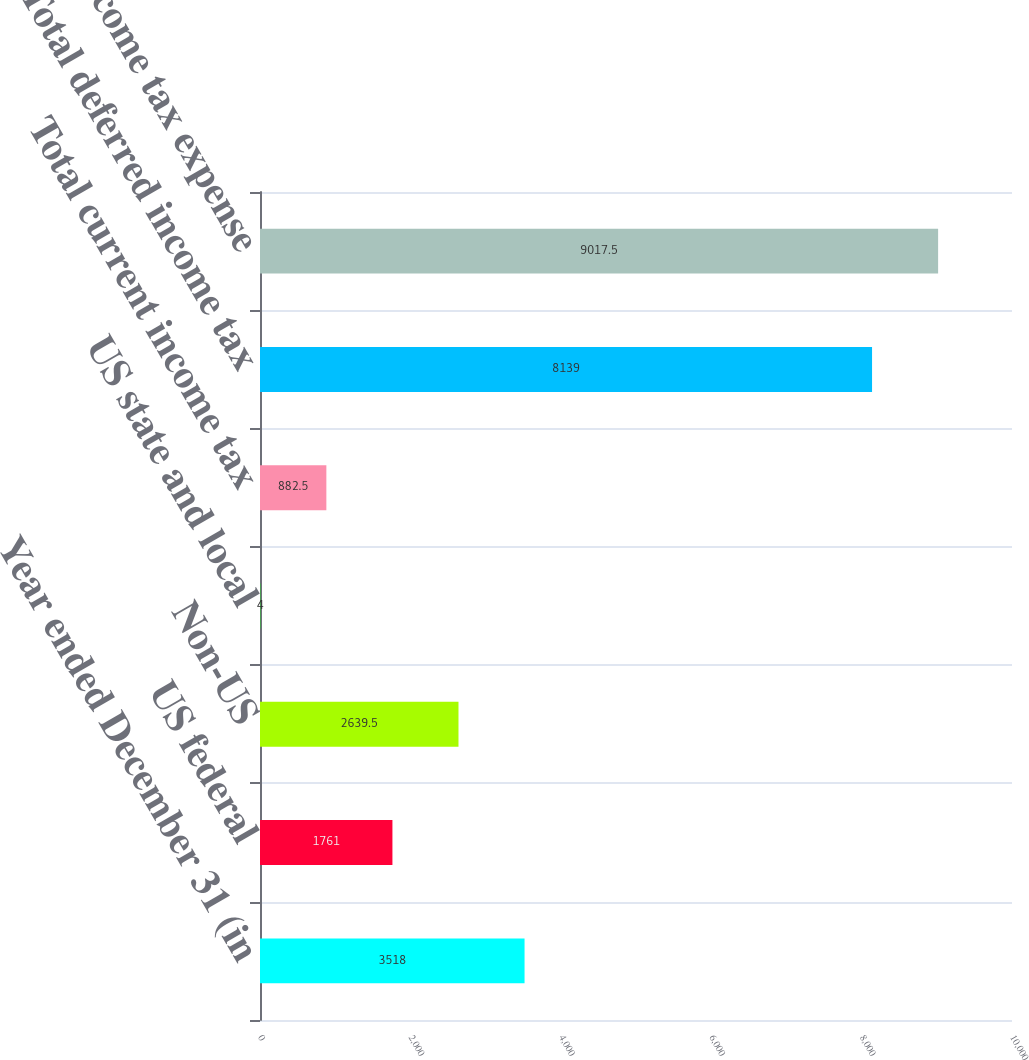<chart> <loc_0><loc_0><loc_500><loc_500><bar_chart><fcel>Year ended December 31 (in<fcel>US federal<fcel>Non-US<fcel>US state and local<fcel>Total current income tax<fcel>Total deferred income tax<fcel>Total income tax expense<nl><fcel>3518<fcel>1761<fcel>2639.5<fcel>4<fcel>882.5<fcel>8139<fcel>9017.5<nl></chart> 